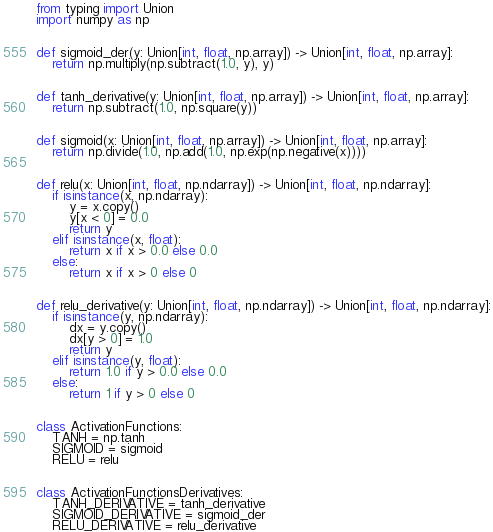<code> <loc_0><loc_0><loc_500><loc_500><_Python_>from typing import Union
import numpy as np


def sigmoid_der(y: Union[int, float, np.array]) -> Union[int, float, np.array]:
    return np.multiply(np.subtract(1.0, y), y)


def tanh_derivative(y: Union[int, float, np.array]) -> Union[int, float, np.array]:
    return np.subtract(1.0, np.square(y))


def sigmoid(x: Union[int, float, np.array]) -> Union[int, float, np.array]:
    return np.divide(1.0, np.add(1.0, np.exp(np.negative(x))))


def relu(x: Union[int, float, np.ndarray]) -> Union[int, float, np.ndarray]:
    if isinstance(x, np.ndarray):
        y = x.copy()
        y[x < 0] = 0.0
        return y
    elif isinstance(x, float):
        return x if x > 0.0 else 0.0
    else:
        return x if x > 0 else 0


def relu_derivative(y: Union[int, float, np.ndarray]) -> Union[int, float, np.ndarray]:
    if isinstance(y, np.ndarray):
        dx = y.copy()
        dx[y > 0] = 1.0
        return y
    elif isinstance(y, float):
        return 1.0 if y > 0.0 else 0.0
    else:
        return 1 if y > 0 else 0


class ActivationFunctions:
    TANH = np.tanh
    SIGMOID = sigmoid
    RELU = relu


class ActivationFunctionsDerivatives:
    TANH_DERIVATIVE = tanh_derivative
    SIGMOID_DERIVATIVE = sigmoid_der
    RELU_DERIVATIVE = relu_derivative

</code> 